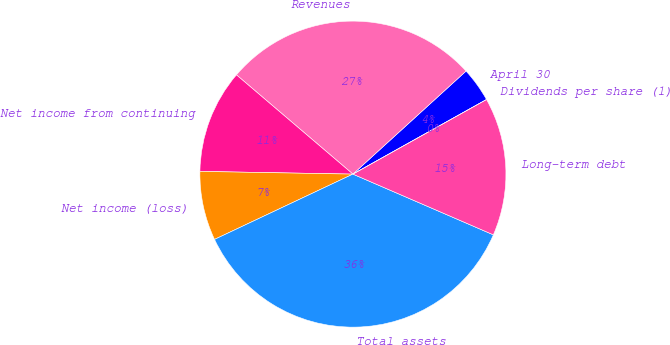Convert chart. <chart><loc_0><loc_0><loc_500><loc_500><pie_chart><fcel>April 30<fcel>Revenues<fcel>Net income from continuing<fcel>Net income (loss)<fcel>Total assets<fcel>Long-term debt<fcel>Dividends per share (1)<nl><fcel>3.65%<fcel>27.01%<fcel>10.95%<fcel>7.3%<fcel>36.49%<fcel>14.6%<fcel>0.0%<nl></chart> 